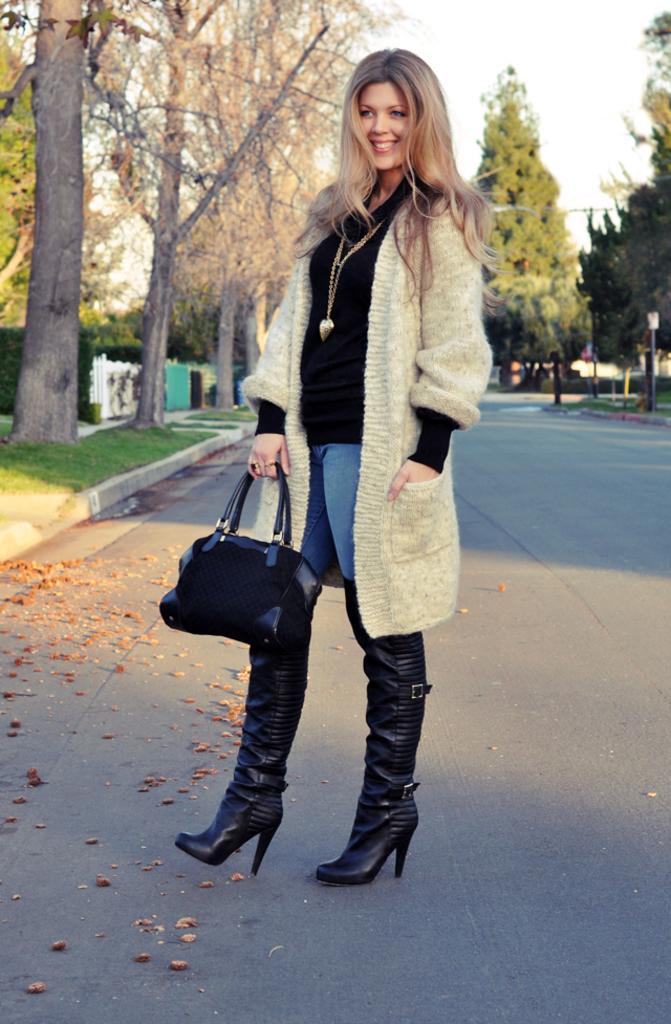Could you give a brief overview of what you see in this image? In this picture there is a woman who is holding a black bag is standing and smiling. At the background there are some trees. 